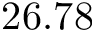Convert formula to latex. <formula><loc_0><loc_0><loc_500><loc_500>2 6 . 7 8</formula> 